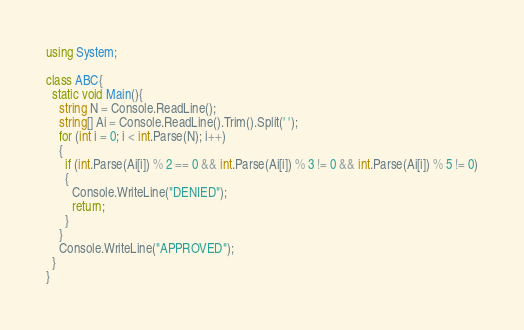<code> <loc_0><loc_0><loc_500><loc_500><_C#_>using System;

class ABC{
  static void Main(){
    string N = Console.ReadLine();
    string[] Ai = Console.ReadLine().Trim().Split(' ');
    for (int i = 0; i < int.Parse(N); i++)
    {
      if (int.Parse(Ai[i]) % 2 == 0 && int.Parse(Ai[i]) % 3 != 0 && int.Parse(Ai[i]) % 5 != 0)
      {
        Console.WriteLine("DENIED");
        return;
      }
    }
    Console.WriteLine("APPROVED");
  }
}</code> 